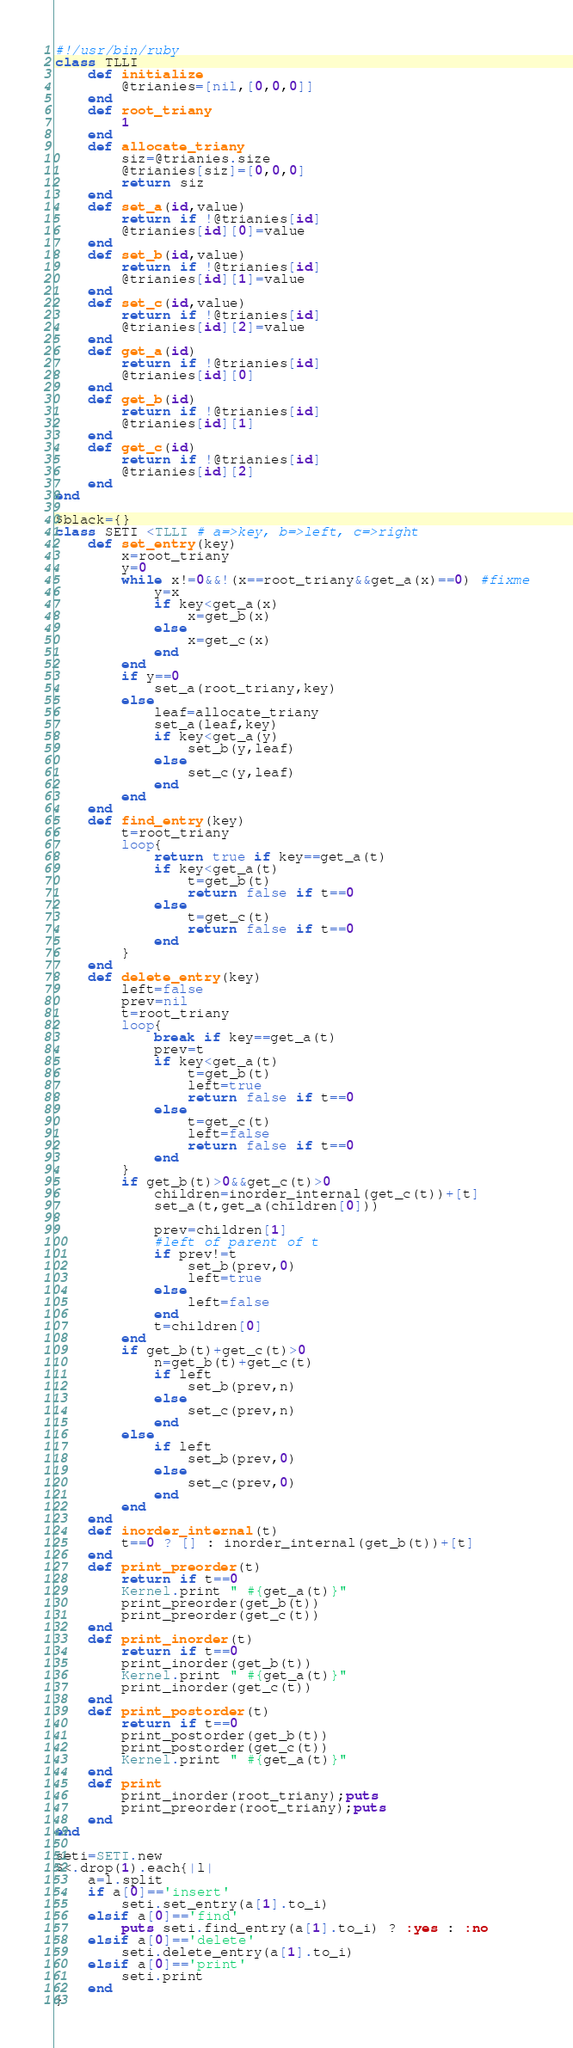<code> <loc_0><loc_0><loc_500><loc_500><_Ruby_>#!/usr/bin/ruby
class TLLI
	def initialize
		@trianies=[nil,[0,0,0]]
	end
	def root_triany
		1
	end
	def allocate_triany
		siz=@trianies.size
		@trianies[siz]=[0,0,0]
		return siz
	end
	def set_a(id,value)
		return if !@trianies[id]
		@trianies[id][0]=value
	end
	def set_b(id,value)
		return if !@trianies[id]
		@trianies[id][1]=value
	end
	def set_c(id,value)
		return if !@trianies[id]
		@trianies[id][2]=value
	end
	def get_a(id)
		return if !@trianies[id]
		@trianies[id][0]
	end
	def get_b(id)
		return if !@trianies[id]
		@trianies[id][1]
	end
	def get_c(id)
		return if !@trianies[id]
		@trianies[id][2]
	end
end

$black={}
class SETI <TLLI # a=>key, b=>left, c=>right
	def set_entry(key)
		x=root_triany
		y=0
		while x!=0&&!(x==root_triany&&get_a(x)==0) #fixme
			y=x
			if key<get_a(x)
				x=get_b(x)
			else
				x=get_c(x)
			end
		end
		if y==0
			set_a(root_triany,key)
		else
			leaf=allocate_triany
			set_a(leaf,key)
			if key<get_a(y)
				set_b(y,leaf)
			else
				set_c(y,leaf)
			end
		end
	end
	def find_entry(key)
		t=root_triany
		loop{
			return true if key==get_a(t)
			if key<get_a(t)
				t=get_b(t)
				return false if t==0
			else
				t=get_c(t)
				return false if t==0
			end
		}
	end
	def delete_entry(key)
		left=false
		prev=nil
		t=root_triany
		loop{
			break if key==get_a(t)
			prev=t
			if key<get_a(t)
				t=get_b(t)
				left=true
				return false if t==0
			else
				t=get_c(t)
				left=false
				return false if t==0
			end
		}
		if get_b(t)>0&&get_c(t)>0
			children=inorder_internal(get_c(t))+[t]
			set_a(t,get_a(children[0]))

			prev=children[1]
			#left of parent of t
			if prev!=t
				set_b(prev,0)
				left=true
			else
				left=false
			end
			t=children[0]
		end
		if get_b(t)+get_c(t)>0
			n=get_b(t)+get_c(t)
			if left
				set_b(prev,n)
			else
				set_c(prev,n)
			end
		else
			if left
				set_b(prev,0)
			else
				set_c(prev,0)
			end
		end
	end
	def inorder_internal(t)
		t==0 ? [] : inorder_internal(get_b(t))+[t]
	end
	def print_preorder(t)
		return if t==0
		Kernel.print " #{get_a(t)}"
		print_preorder(get_b(t))
		print_preorder(get_c(t))
	end
	def print_inorder(t)
		return if t==0
		print_inorder(get_b(t))
		Kernel.print " #{get_a(t)}"
		print_inorder(get_c(t))
	end
	def print_postorder(t)
		return if t==0
		print_postorder(get_b(t))
		print_postorder(get_c(t))
		Kernel.print " #{get_a(t)}"
	end
	def print
		print_inorder(root_triany);puts
		print_preorder(root_triany);puts
	end
end

seti=SETI.new
$<.drop(1).each{|l|
	a=l.split
	if a[0]=='insert'
		seti.set_entry(a[1].to_i)
	elsif a[0]=='find'
		puts seti.find_entry(a[1].to_i) ? :yes : :no
	elsif a[0]=='delete'
		seti.delete_entry(a[1].to_i)
	elsif a[0]=='print'
		seti.print
	end
}</code> 